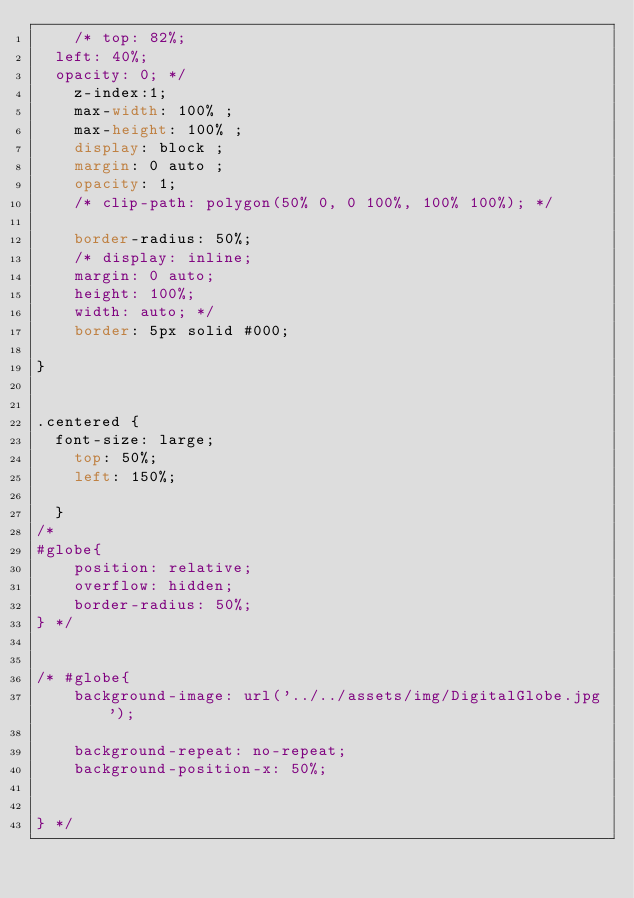Convert code to text. <code><loc_0><loc_0><loc_500><loc_500><_CSS_>    /* top: 82%;
  left: 40%;
  opacity: 0; */
    z-index:1;
    max-width: 100% ;
    max-height: 100% ;
    display: block ;
    margin: 0 auto ;
    opacity: 1;
    /* clip-path: polygon(50% 0, 0 100%, 100% 100%); */

    border-radius: 50%;
    /* display: inline;
    margin: 0 auto;
    height: 100%;
    width: auto; */
    border: 5px solid #000;
  
}


.centered {
  font-size: large;
    top: 50%;
    left: 150%;
  
  }
/* 
#globe{
    position: relative;
    overflow: hidden;
    border-radius: 50%;
} */


/* #globe{
    background-image: url('../../assets/img/DigitalGlobe.jpg');
    
    background-repeat: no-repeat;
    background-position-x: 50%;
    
 
} */

</code> 